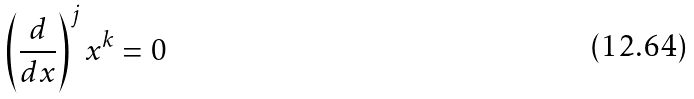<formula> <loc_0><loc_0><loc_500><loc_500>\left ( \frac { d } { d x } \right ) ^ { j } x ^ { k } = 0</formula> 